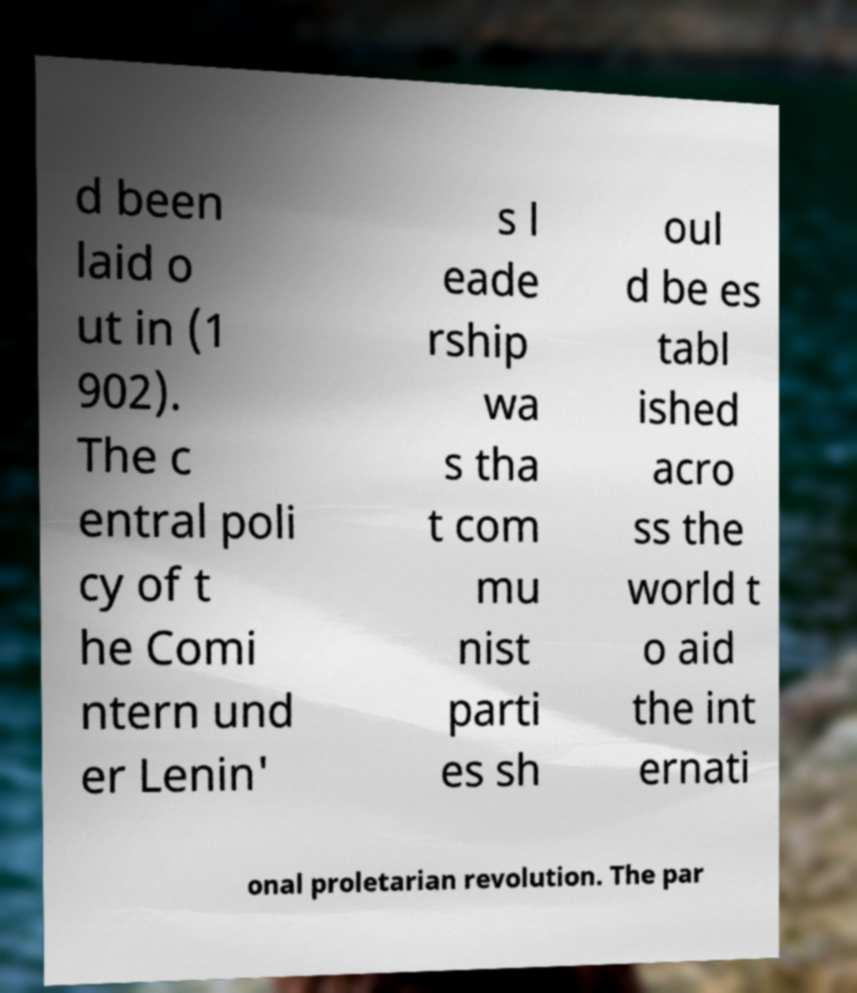There's text embedded in this image that I need extracted. Can you transcribe it verbatim? d been laid o ut in (1 902). The c entral poli cy of t he Comi ntern und er Lenin' s l eade rship wa s tha t com mu nist parti es sh oul d be es tabl ished acro ss the world t o aid the int ernati onal proletarian revolution. The par 